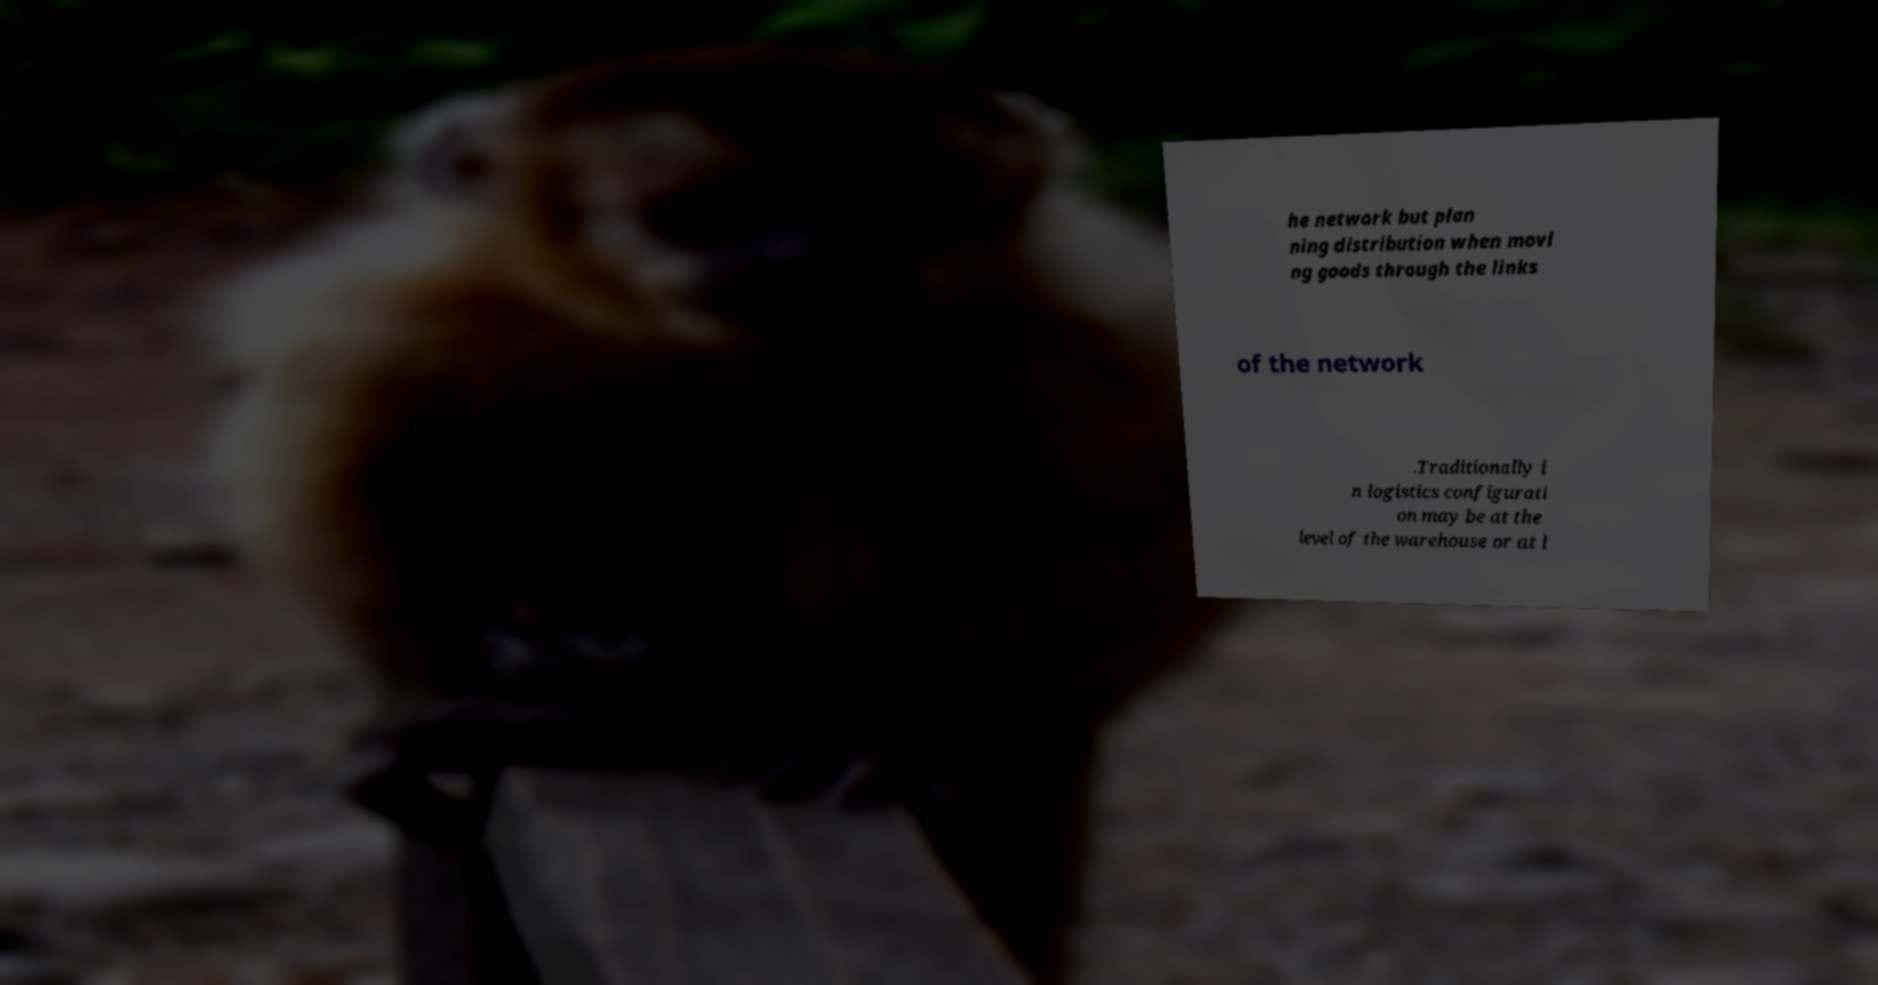Could you assist in decoding the text presented in this image and type it out clearly? he network but plan ning distribution when movi ng goods through the links of the network .Traditionally i n logistics configurati on may be at the level of the warehouse or at l 